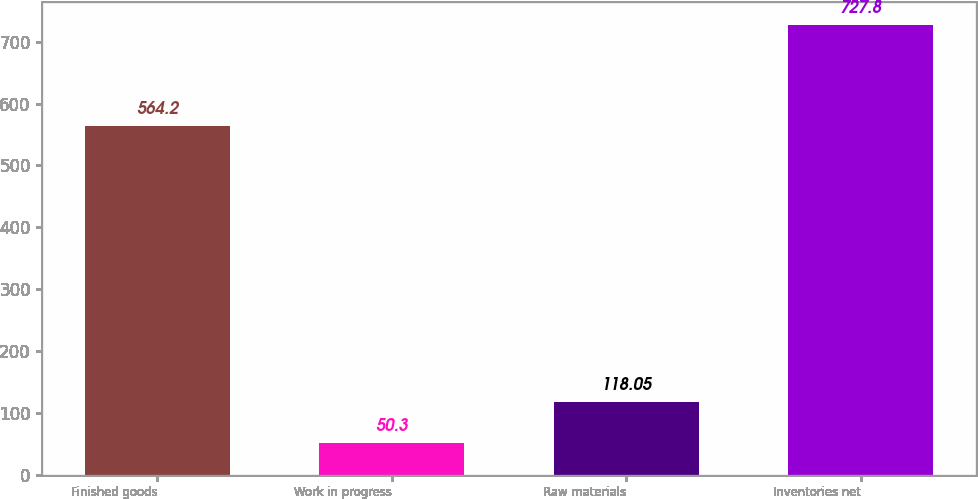Convert chart to OTSL. <chart><loc_0><loc_0><loc_500><loc_500><bar_chart><fcel>Finished goods<fcel>Work in progress<fcel>Raw materials<fcel>Inventories net<nl><fcel>564.2<fcel>50.3<fcel>118.05<fcel>727.8<nl></chart> 